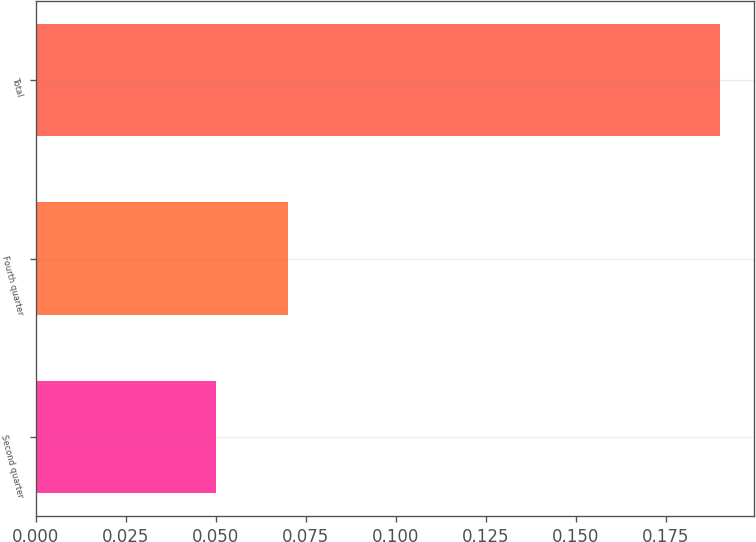Convert chart. <chart><loc_0><loc_0><loc_500><loc_500><bar_chart><fcel>Second quarter<fcel>Fourth quarter<fcel>Total<nl><fcel>0.05<fcel>0.07<fcel>0.19<nl></chart> 